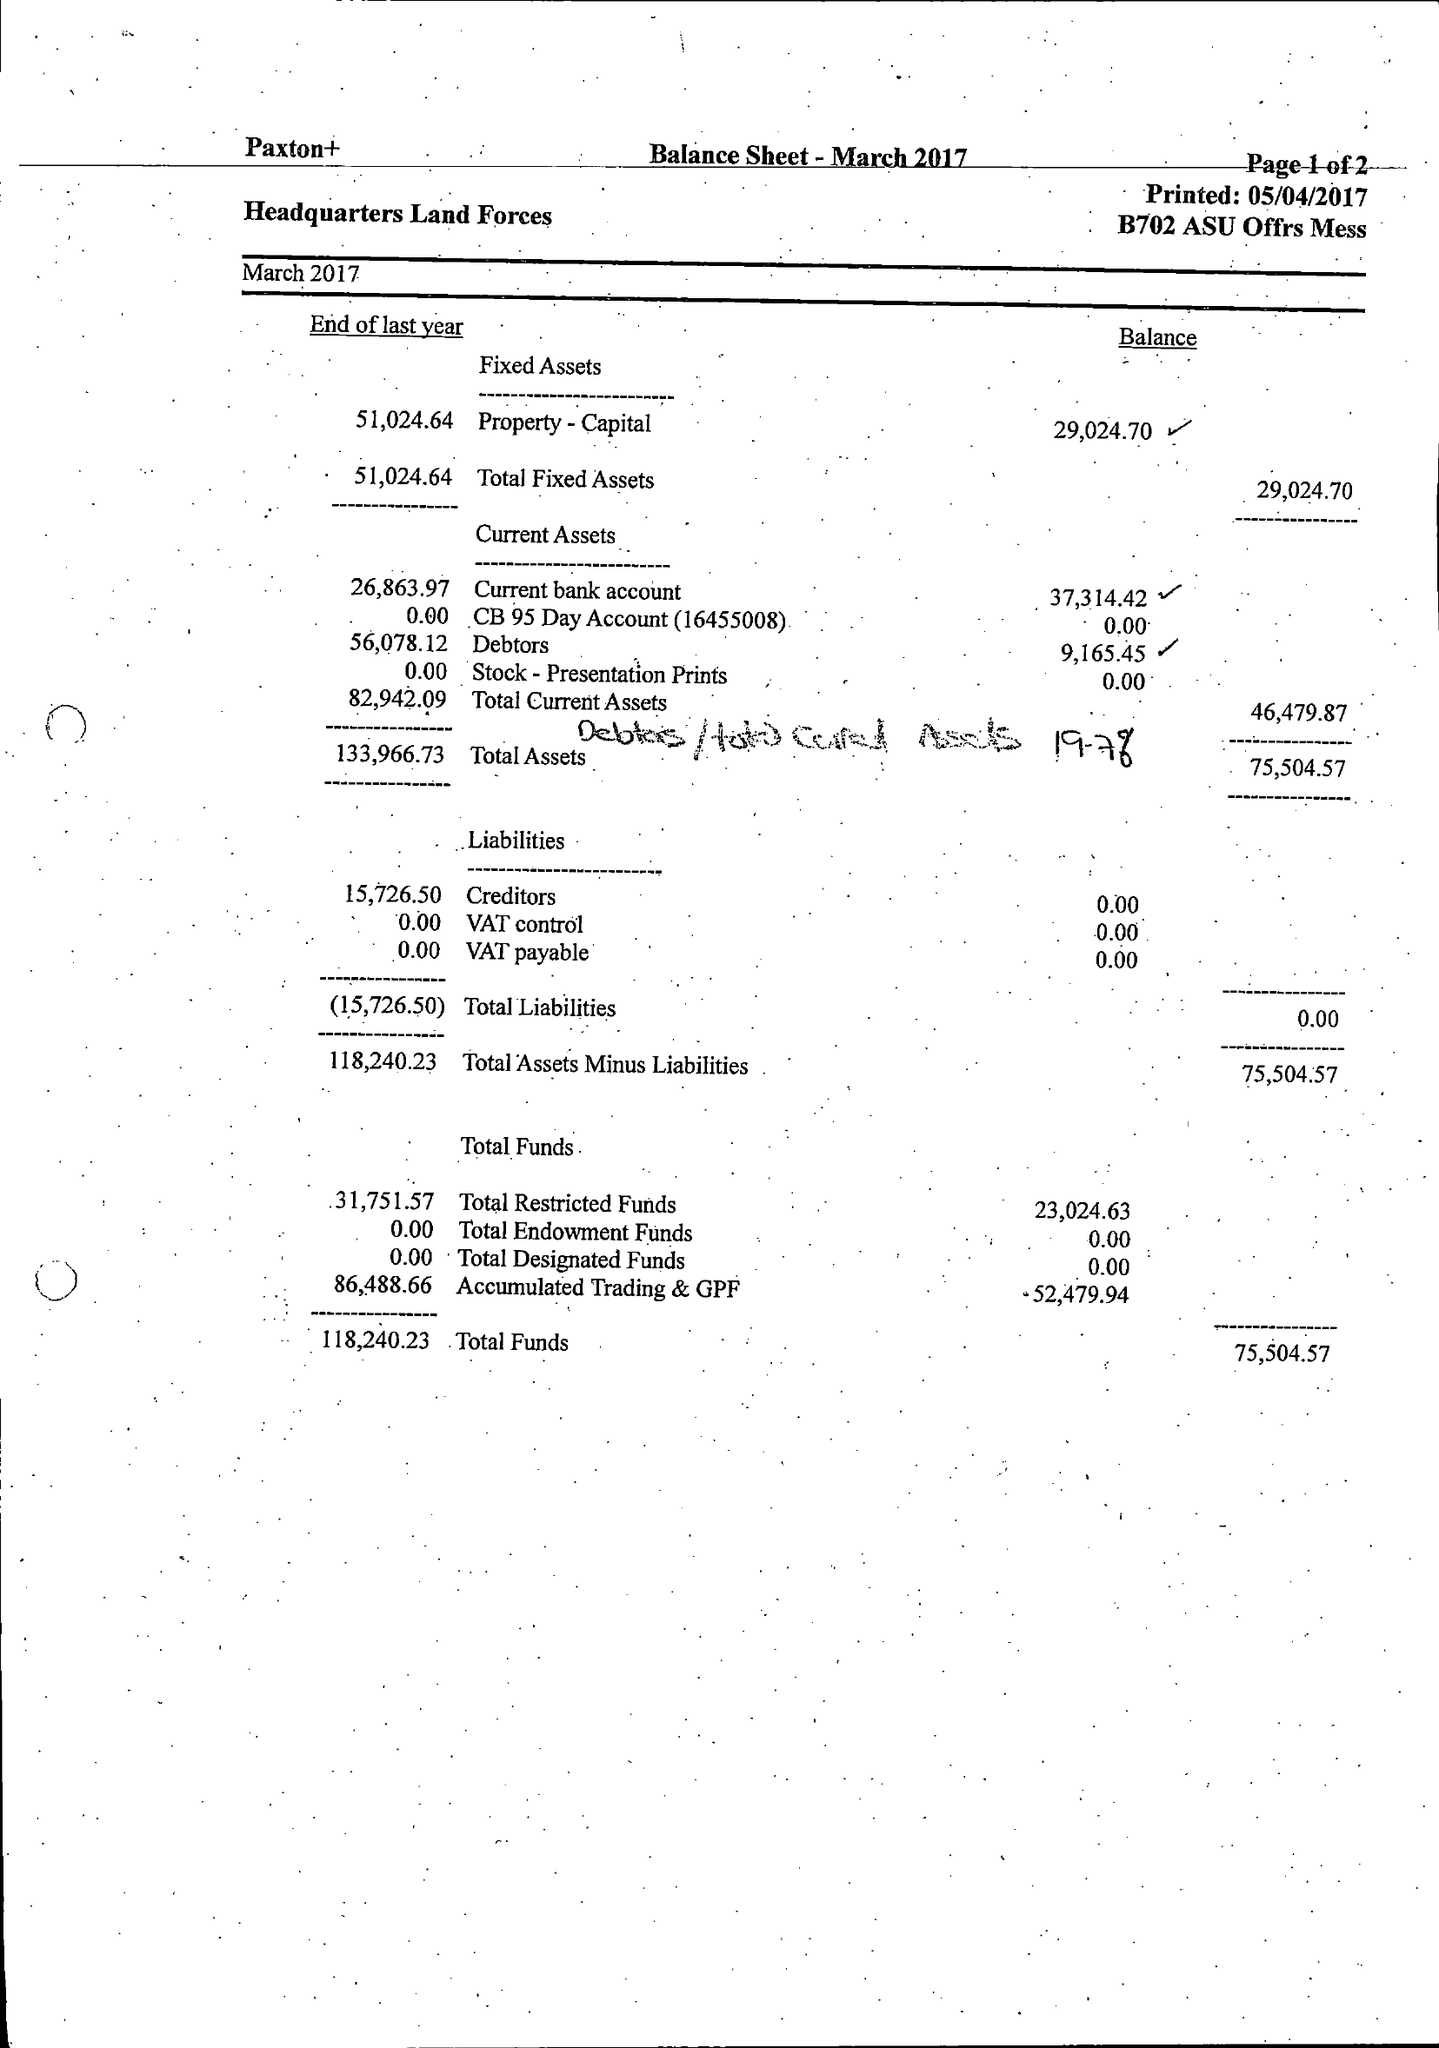What is the value for the report_date?
Answer the question using a single word or phrase. 2017-03-31 